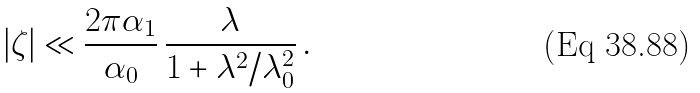Convert formula to latex. <formula><loc_0><loc_0><loc_500><loc_500>| \zeta | \ll \frac { 2 \pi \alpha _ { 1 } } { \alpha _ { 0 } } \, \frac { \lambda } { 1 + \lambda ^ { 2 } / \lambda _ { 0 } ^ { 2 } } \, .</formula> 